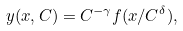<formula> <loc_0><loc_0><loc_500><loc_500>y ( x , C ) = C ^ { - \gamma } f ( x / C ^ { \delta } ) ,</formula> 